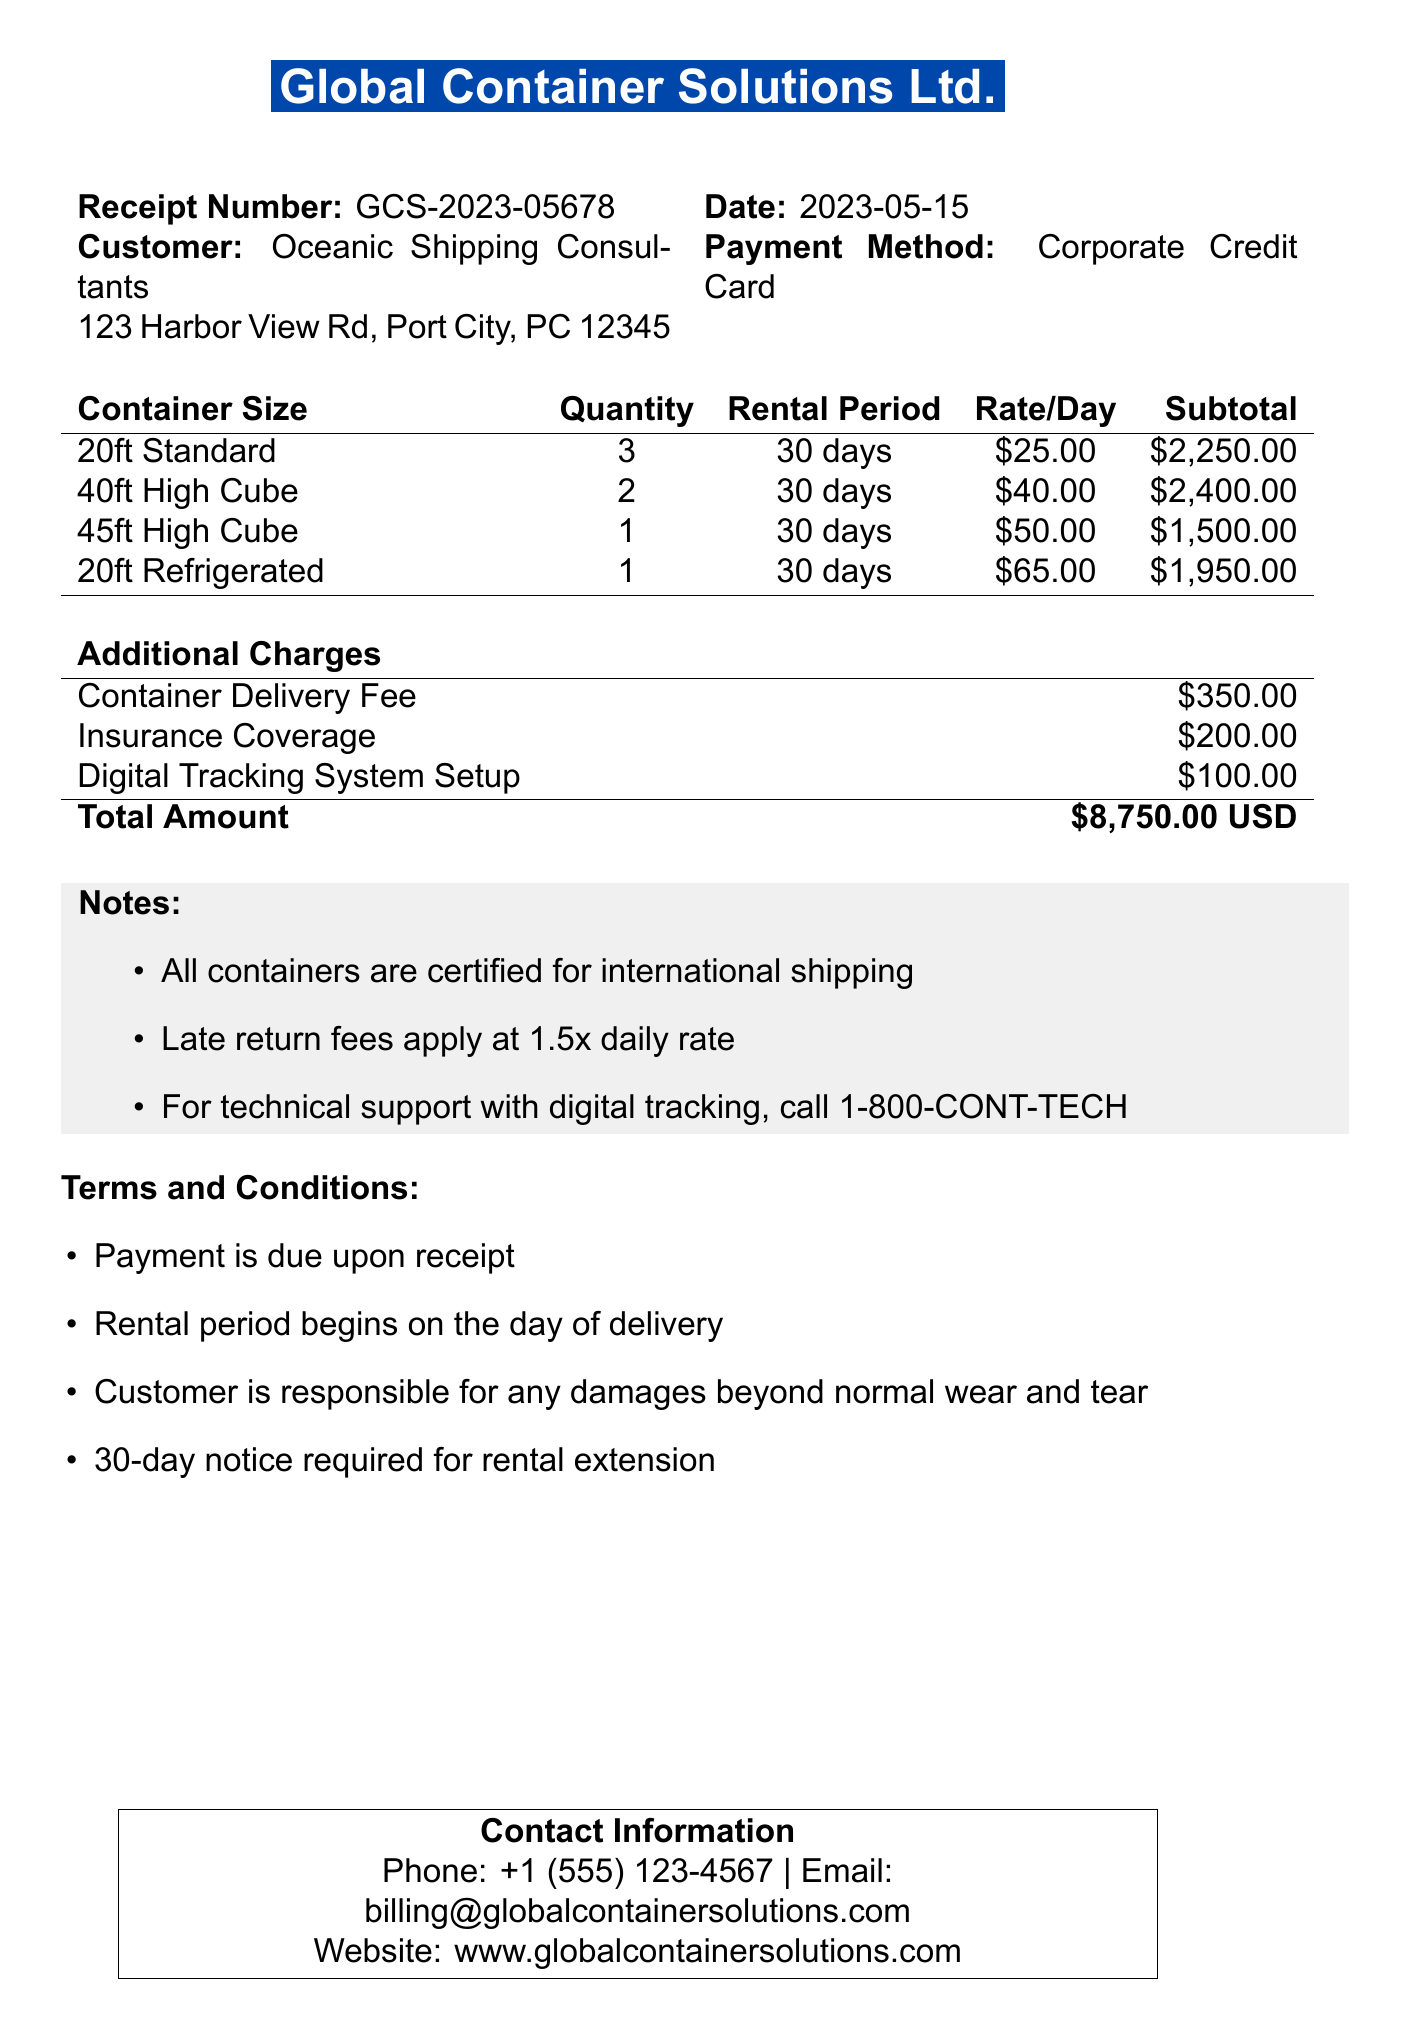What is the company name? The company name is indicated at the top of the document.
Answer: Global Container Solutions Ltd What is the receipt number? The receipt number is specifically stated in the document as a unique identifier.
Answer: GCS-2023-05678 What is the total amount due? The total amount due is clearly listed at the end of the itemized billing section.
Answer: $8,750.00 USD How many 40ft High Cube containers were rented? The quantity of 40ft High Cube containers is specified in the item list.
Answer: 2 What is the rental period for the containers? The rental period is a standard duration mentioned for each line item in the document.
Answer: 30 days What additional charge is specified for insurance coverage? Additional charges are itemized, including insurance coverage.
Answer: $200.00 What is stated about late return fees? The notes section outlines the policy regarding late returns.
Answer: Late return fees apply at 1.5x daily rate How can customers contact for technical support? The notes provide a specific phone number for technical support related to digital tracking.
Answer: 1-800-CONT-TECH What is required for a rental extension? The terms and conditions detail the requirements for extending a rental period.
Answer: 30-day notice required for rental extension 